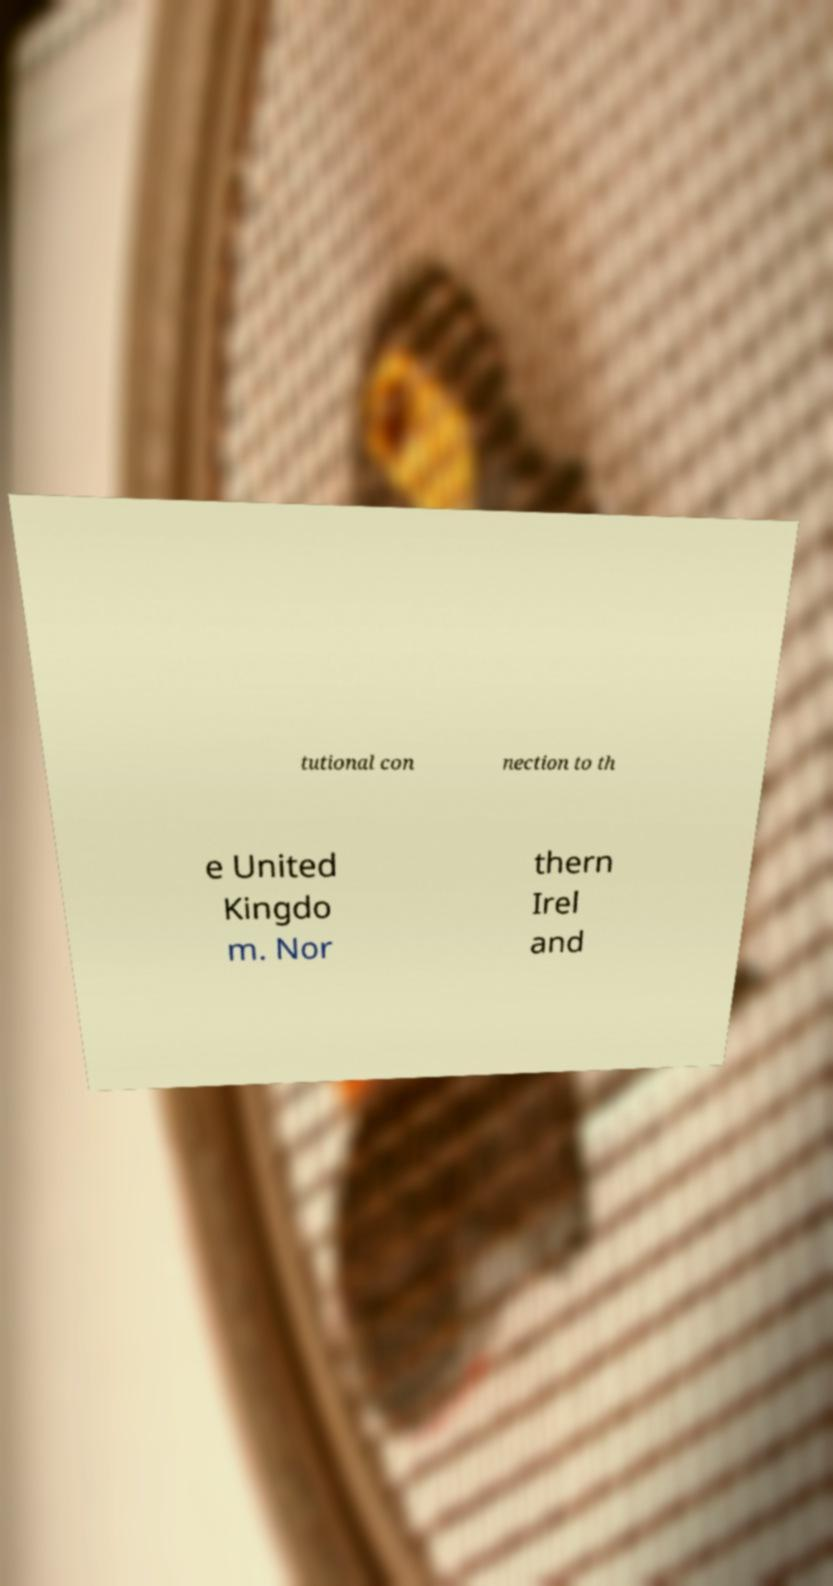Please identify and transcribe the text found in this image. tutional con nection to th e United Kingdo m. Nor thern Irel and 